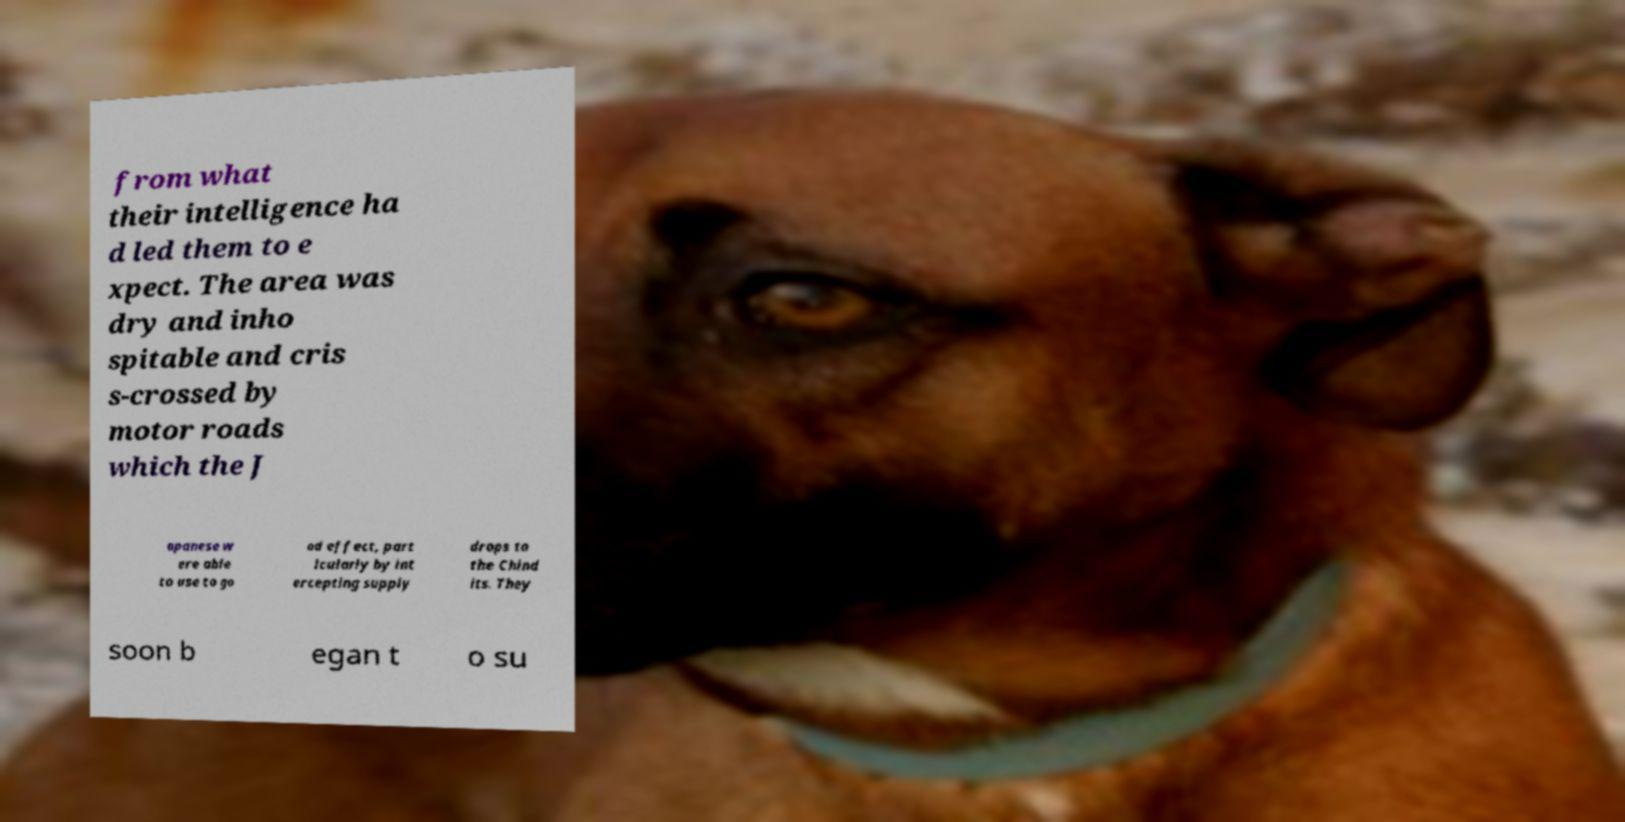For documentation purposes, I need the text within this image transcribed. Could you provide that? from what their intelligence ha d led them to e xpect. The area was dry and inho spitable and cris s-crossed by motor roads which the J apanese w ere able to use to go od effect, part icularly by int ercepting supply drops to the Chind its. They soon b egan t o su 